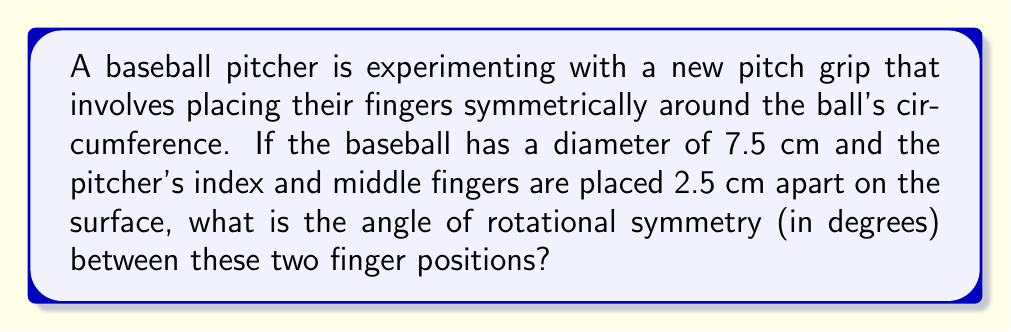Could you help me with this problem? Let's approach this step-by-step:

1) First, we need to understand that the angle of rotational symmetry will be the central angle subtended by the arc between the two finger positions.

2) We can find this angle using the arc length formula:
   $$ \theta = \frac{s}{r} $$
   where $\theta$ is the central angle in radians, $s$ is the arc length (distance between fingers), and $r$ is the radius of the ball.

3) We're given the diameter of the ball (7.5 cm), so the radius is:
   $$ r = \frac{7.5}{2} = 3.75 \text{ cm} $$

4) The arc length $s$ is the distance between the fingers, which is 2.5 cm.

5) Now we can plug these values into our formula:
   $$ \theta = \frac{2.5}{3.75} = \frac{2}{3} \text{ radians} $$

6) To convert this to degrees, we multiply by $\frac{180}{\pi}$:
   $$ \theta_{\text{degrees}} = \frac{2}{3} \cdot \frac{180}{\pi} \approx 38.2^{\circ} $$

7) This is the angle of rotational symmetry between the two finger positions.
Answer: $38.2^{\circ}$ 